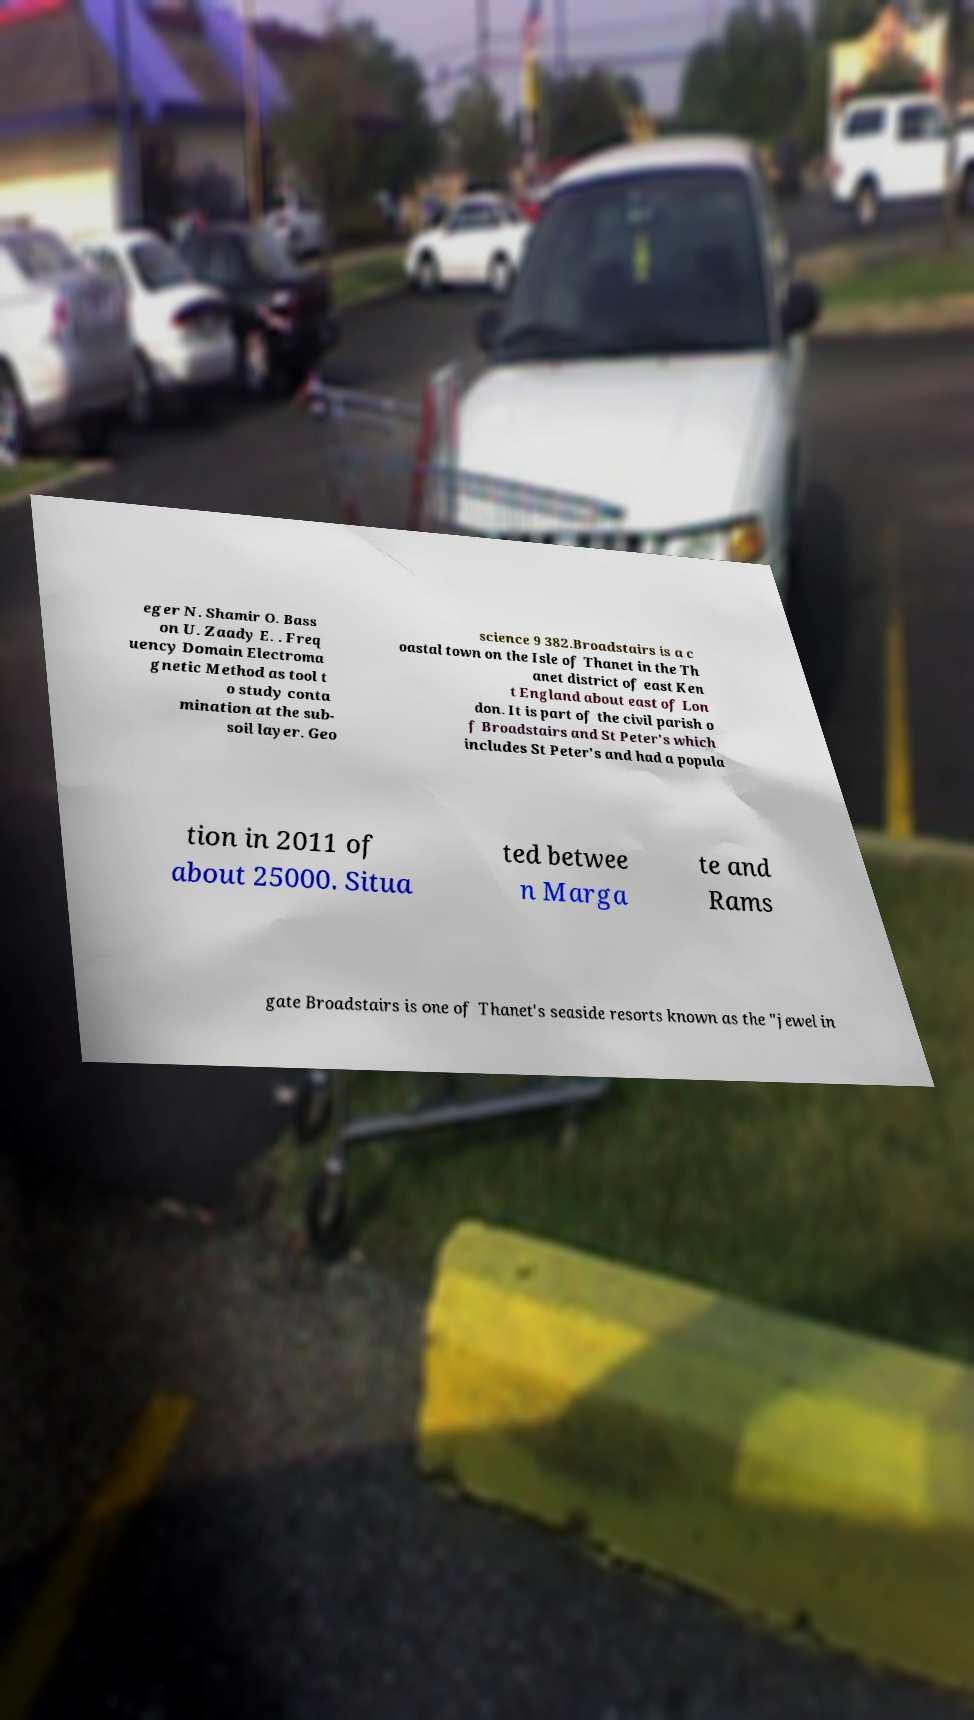Could you extract and type out the text from this image? eger N. Shamir O. Bass on U. Zaady E. . Freq uency Domain Electroma gnetic Method as tool t o study conta mination at the sub- soil layer. Geo science 9 382.Broadstairs is a c oastal town on the Isle of Thanet in the Th anet district of east Ken t England about east of Lon don. It is part of the civil parish o f Broadstairs and St Peter's which includes St Peter's and had a popula tion in 2011 of about 25000. Situa ted betwee n Marga te and Rams gate Broadstairs is one of Thanet's seaside resorts known as the "jewel in 